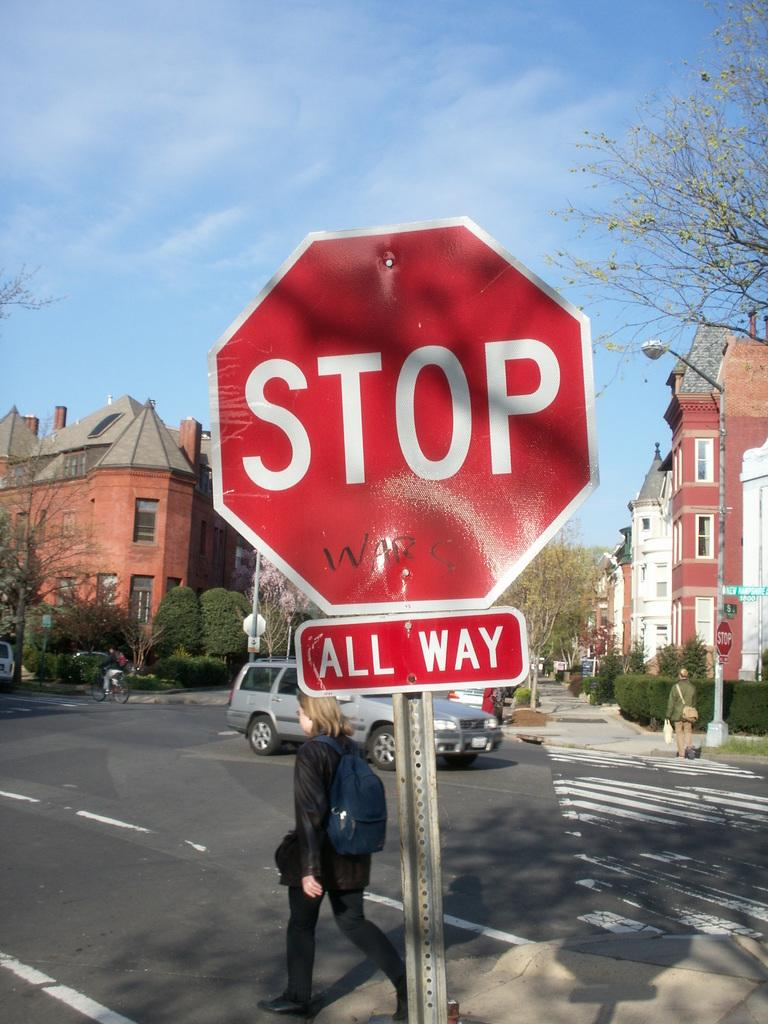<image>
Share a concise interpretation of the image provided. a stop sign that says all way on it near a girl 